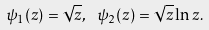Convert formula to latex. <formula><loc_0><loc_0><loc_500><loc_500>\psi _ { 1 } ( z ) = \sqrt { z } , \ \psi _ { 2 } ( z ) = \sqrt { z } \ln z .</formula> 